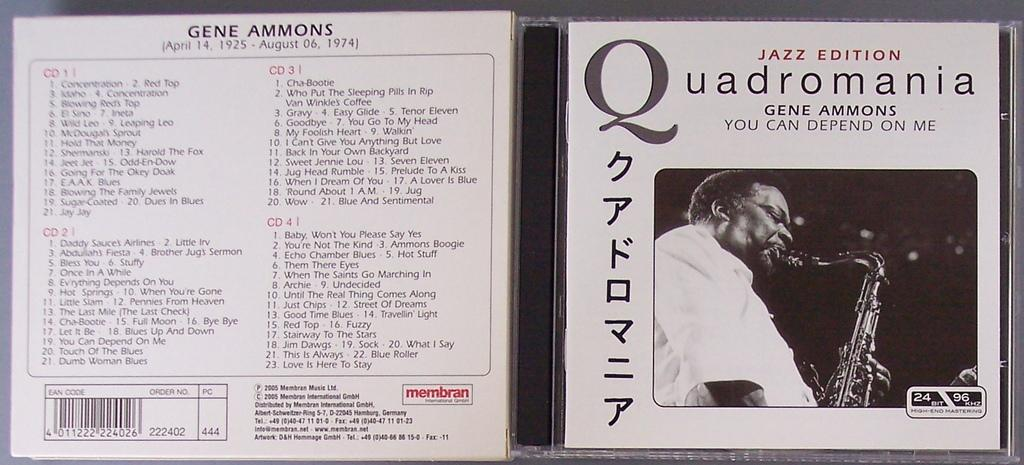<image>
Write a terse but informative summary of the picture. A CD by the artist Gene Ammons titled Quadromania 